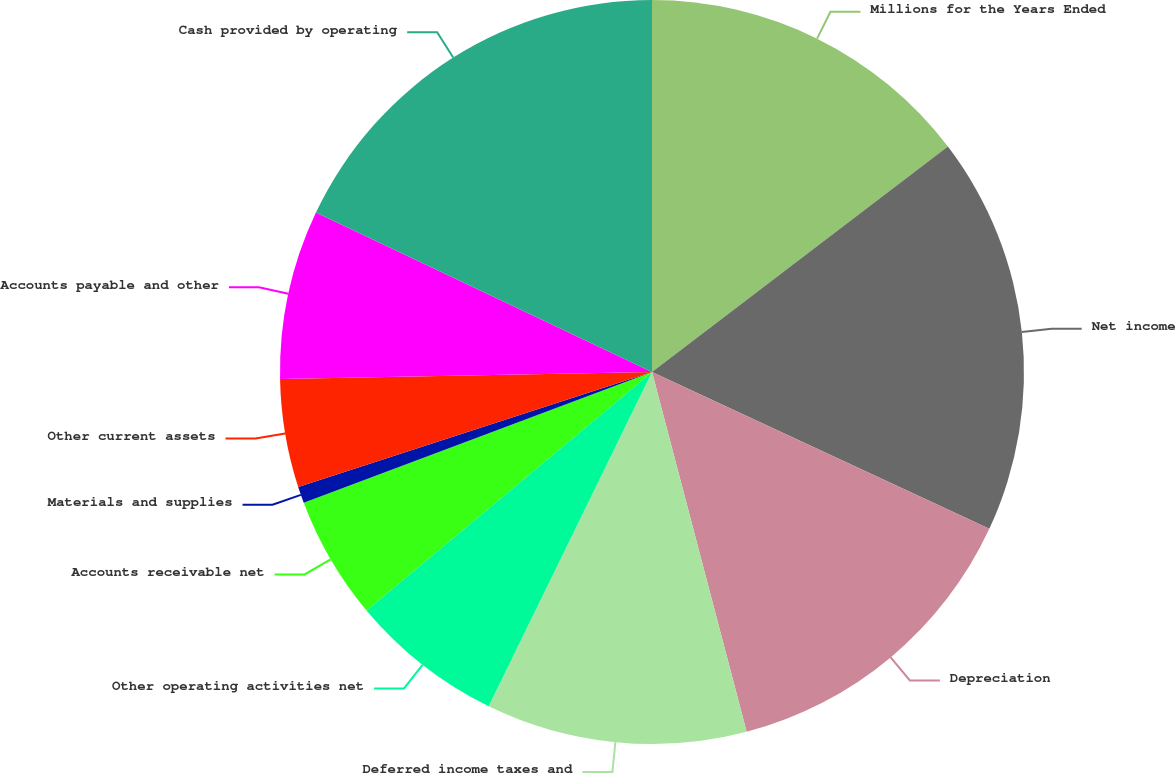Convert chart. <chart><loc_0><loc_0><loc_500><loc_500><pie_chart><fcel>Millions for the Years Ended<fcel>Net income<fcel>Depreciation<fcel>Deferred income taxes and<fcel>Other operating activities net<fcel>Accounts receivable net<fcel>Materials and supplies<fcel>Other current assets<fcel>Accounts payable and other<fcel>Cash provided by operating<nl><fcel>14.64%<fcel>17.29%<fcel>13.98%<fcel>11.33%<fcel>6.69%<fcel>5.36%<fcel>0.72%<fcel>4.7%<fcel>7.35%<fcel>17.95%<nl></chart> 